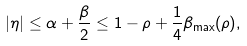<formula> <loc_0><loc_0><loc_500><loc_500>| \eta | \leq \alpha + \frac { \beta } { 2 } \leq 1 - \rho + \frac { 1 } { 4 } \beta _ { \max } ( \rho ) ,</formula> 